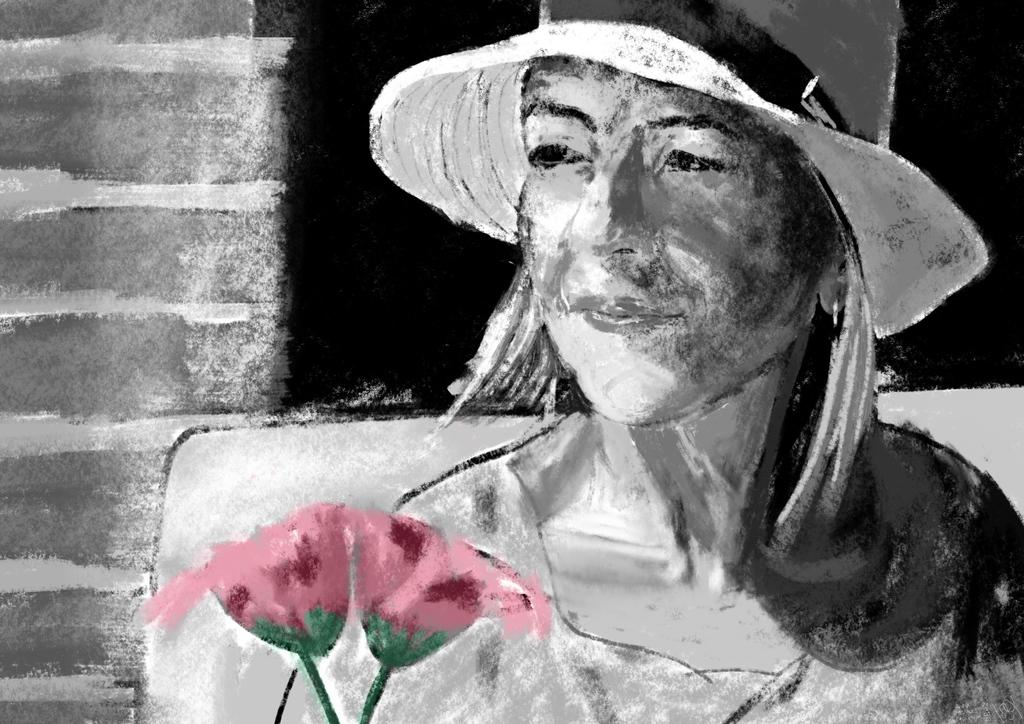What is the main subject of the painting in the image? The main subject of the painting in the image is a woman. What other objects or elements can be seen in the painting? There are two flowers in the painting. What is the color of the flowers? The flowers are pink in color. What is the color scheme of the remaining elements in the painting? The remaining elements in the painting are in black and white colors. How many sisters are depicted in the painting? There are no sisters depicted in the painting; it features a woman and two flowers. What type of thought process can be seen in the painting? There is no indication of a thought process in the painting, as it is a visual representation of a woman and flowers. 